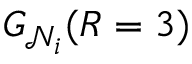<formula> <loc_0><loc_0><loc_500><loc_500>G _ { \mathcal { N } _ { i } } ( R = 3 )</formula> 